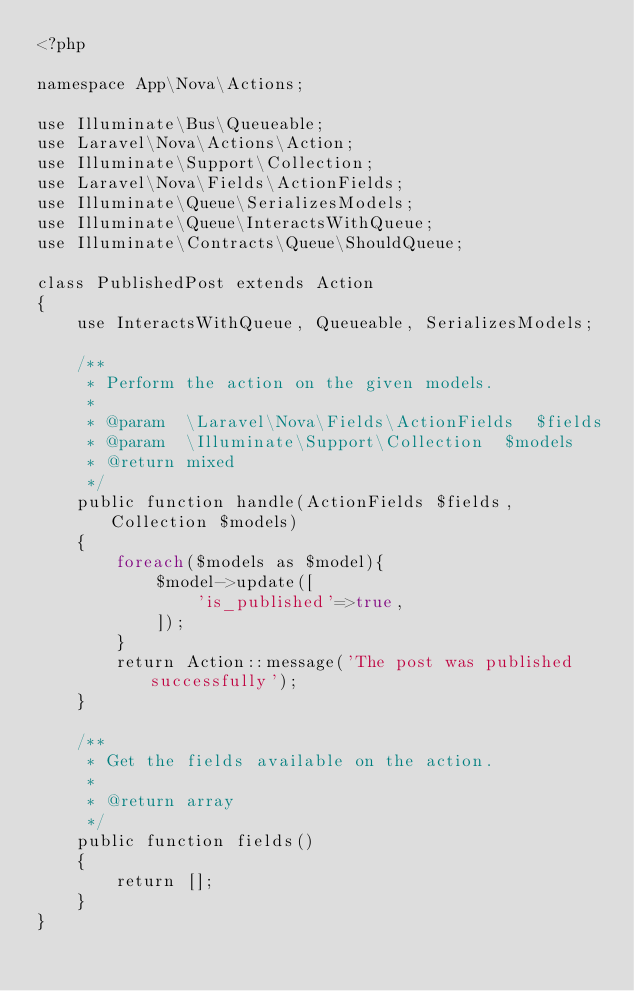Convert code to text. <code><loc_0><loc_0><loc_500><loc_500><_PHP_><?php

namespace App\Nova\Actions;

use Illuminate\Bus\Queueable;
use Laravel\Nova\Actions\Action;
use Illuminate\Support\Collection;
use Laravel\Nova\Fields\ActionFields;
use Illuminate\Queue\SerializesModels;
use Illuminate\Queue\InteractsWithQueue;
use Illuminate\Contracts\Queue\ShouldQueue;

class PublishedPost extends Action
{
    use InteractsWithQueue, Queueable, SerializesModels;

    /**
     * Perform the action on the given models.
     *
     * @param  \Laravel\Nova\Fields\ActionFields  $fields
     * @param  \Illuminate\Support\Collection  $models
     * @return mixed
     */
    public function handle(ActionFields $fields, Collection $models)
    {
        foreach($models as $model){
            $model->update([
                'is_published'=>true,
            ]);
        }
        return Action::message('The post was published successfully');
    }

    /**
     * Get the fields available on the action.
     *
     * @return array
     */
    public function fields()
    {
        return [];
    }
}
</code> 